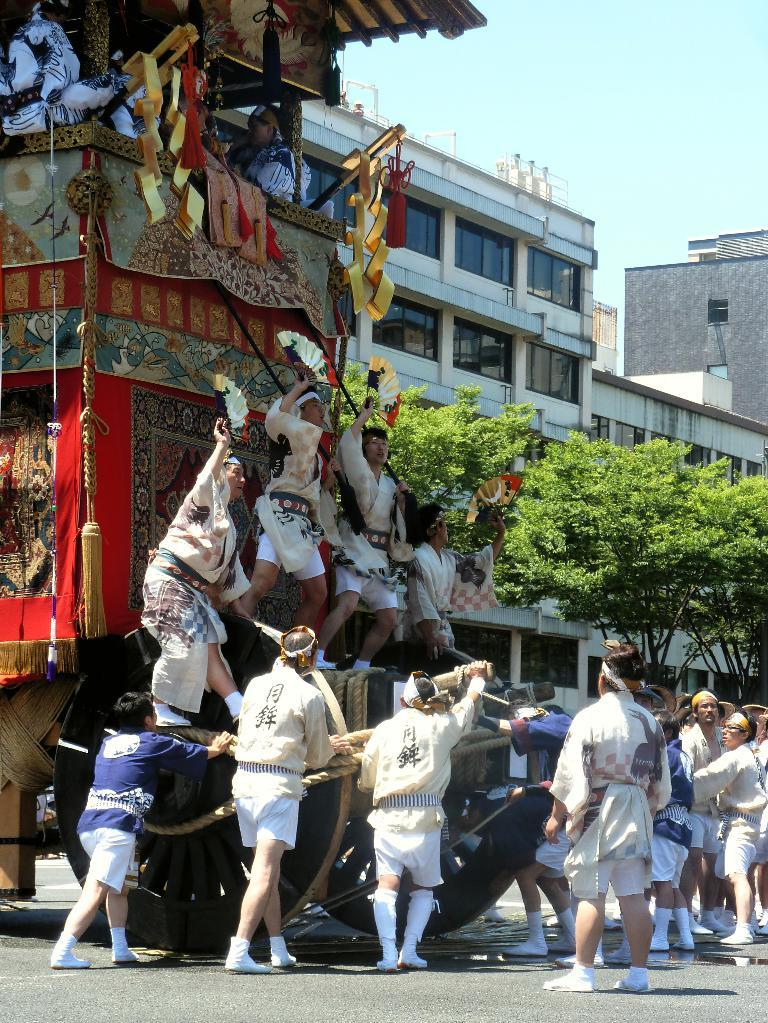Who or what is the main subject in the image? There is a person in the image. What type of natural elements can be seen in the image? There are plants in the image. What type of structure is visible in the image? There is a building with windows in the image. Can you describe any other objects present in the image? There are other objects present in the image, but their specific details are not mentioned in the provided facts. What type of marble is being used to create the person's sculpture in the image? There is no mention of a sculpture or marble in the provided facts, so we cannot answer this question. 